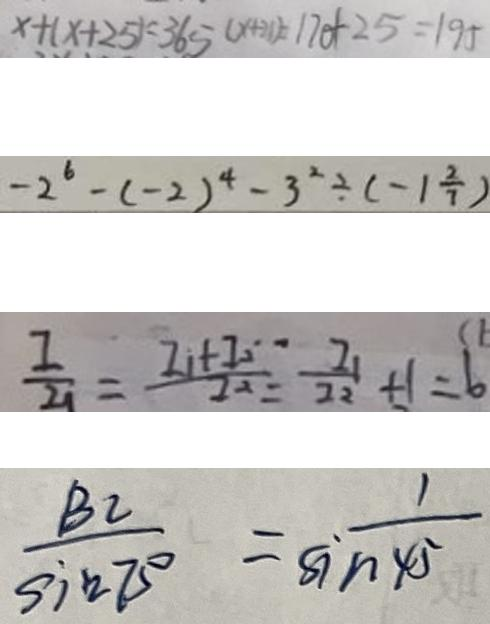Convert formula to latex. <formula><loc_0><loc_0><loc_500><loc_500>x + ( x + 2 5 ) = 3 6 5 ( x + 2 1 ) = 1 7 0 + 2 5 = 1 9 5 
 - 2 ^ { 6 } - ( - 2 ) ^ { 4 } - 3 ^ { 2 } \div ( - 1 \frac { 2 } { 7 } ) 
 \frac { I } { I _ { 1 } } = \frac { I _ { 1 } + I _ { 2 } } { I ^ { 2 } } = \frac { I _ { 1 } } { I _ { 2 } } + 1 = 6 
 \frac { B C } { \sin 7 5 ^ { \circ } } = \frac { 1 } { \sin 4 5 }</formula> 